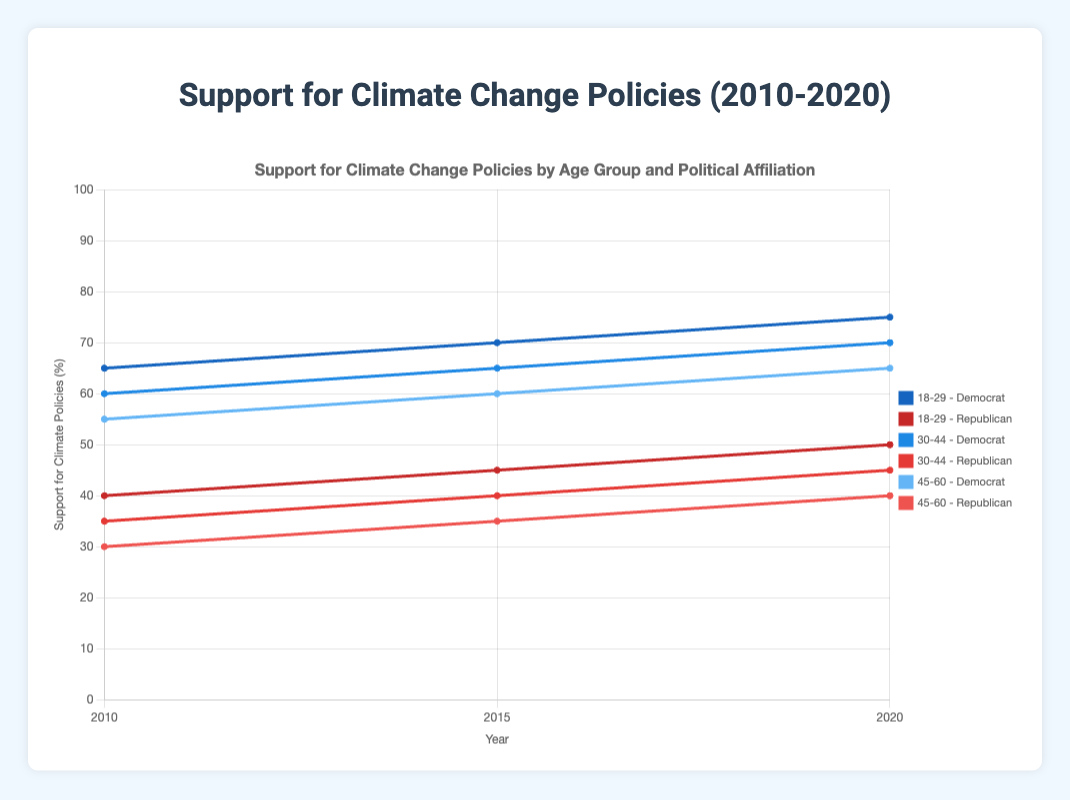What is the trend in support for climate policies among the 18-29 age group across all political affiliations from 2010 to 2020? The support for climate policies in the 18-29 age group among Democrats shows an increasing trend: 65% in 2010, 70% in 2015, and 75% in 2020. Among Republicans, the support also increases from 40% in 2010 to 45% in 2015 and 50% in 2020. The overall trend for the 18-29 age group shows increasing support for climate policies over time.
Answer: Increasing Which political affiliation among the 30-44 age group shows a higher increase in support for climate policies from 2010 to 2020? For Democrats, support increases from 60% in 2010 to 65% in 2015, and then to 70% in 2020, which is a 10% increase. For Republicans, support increases from 35% in 2010 to 40% in 2015, and then to 45% in 2020, which is also a 10% increase. Therefore, both the Democratic and Republican affiliations in the 30-44 age group show the same increase in support for climate policies.
Answer: Both In which year did the support for climate policies among Republicans aged 45-60 reach 40%? By examining the data points for the Republican 45-60 age group, the support reaches 40% in the year 2020.
Answer: 2020 What is the average support for climate policies among Democrats in the 45-60 age group over the three years? The support for climate policies among Democrats aged 45-60 is 55% in 2010, 60% in 2015, and 65% in 2020. To find the average: (55 + 60 + 65) / 3 = 180 / 3 = 60
Answer: 60 Compare the support for climate policies in 2020 for the 18-29 and 45-60 age groups among Republicans. Which age group shows higher support? In 2020, the support for climate policies for Republicans aged 18-29 is 50%, while for those aged 45-60, it is 40%. The 18-29 age group shows higher support.
Answer: 18-29 What is the difference in support for climate policies between Democrats and Republicans in the 18-29 age group in 2015? In 2015, the support for climate policies among Democrats aged 18-29 is 70%, and among Republicans, it is 45%. The difference is 70% - 45% = 25%.
Answer: 25% Which age group and political affiliation combination shows the least support for climate policies in 2010? By looking at the data, Republicans aged 45-60 show the least support for climate policies in 2010 with 30%.
Answer: Republicans aged 45-60 How does the support for climate policies among the 45-60 age group of Republicans change from 2010 to 2020? From 2010 to 2020, the support for climate policies among the Republican 45-60 age group increases from 30% to 40%. The change over time indicates an increase of 10%.
Answer: Increase by 10% For the 30-44 age group, which political affiliation shows a higher support for climate policies in 2015? In 2015, the support for climate policies among the 30-44 age group is 65% for Democrats and 40% for Republicans. Therefore, Democrats show higher support.
Answer: Democrats What is the overall trend in support for climate policies among all age groups and political affiliations from 2010 to 2020? Considering the data for all age groups and political affiliations, support for climate policies generally increases over time. Democrats across all age groups show a consistent increase, while Republicans also show an increase but at a slower rate. The overall trend is an increasing support for climate policies from 2010 to 2020.
Answer: Increasing 